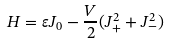<formula> <loc_0><loc_0><loc_500><loc_500>H = \varepsilon J _ { 0 } - { \frac { V } { 2 } } ( J _ { + } ^ { 2 } + J _ { - } ^ { 2 } )</formula> 